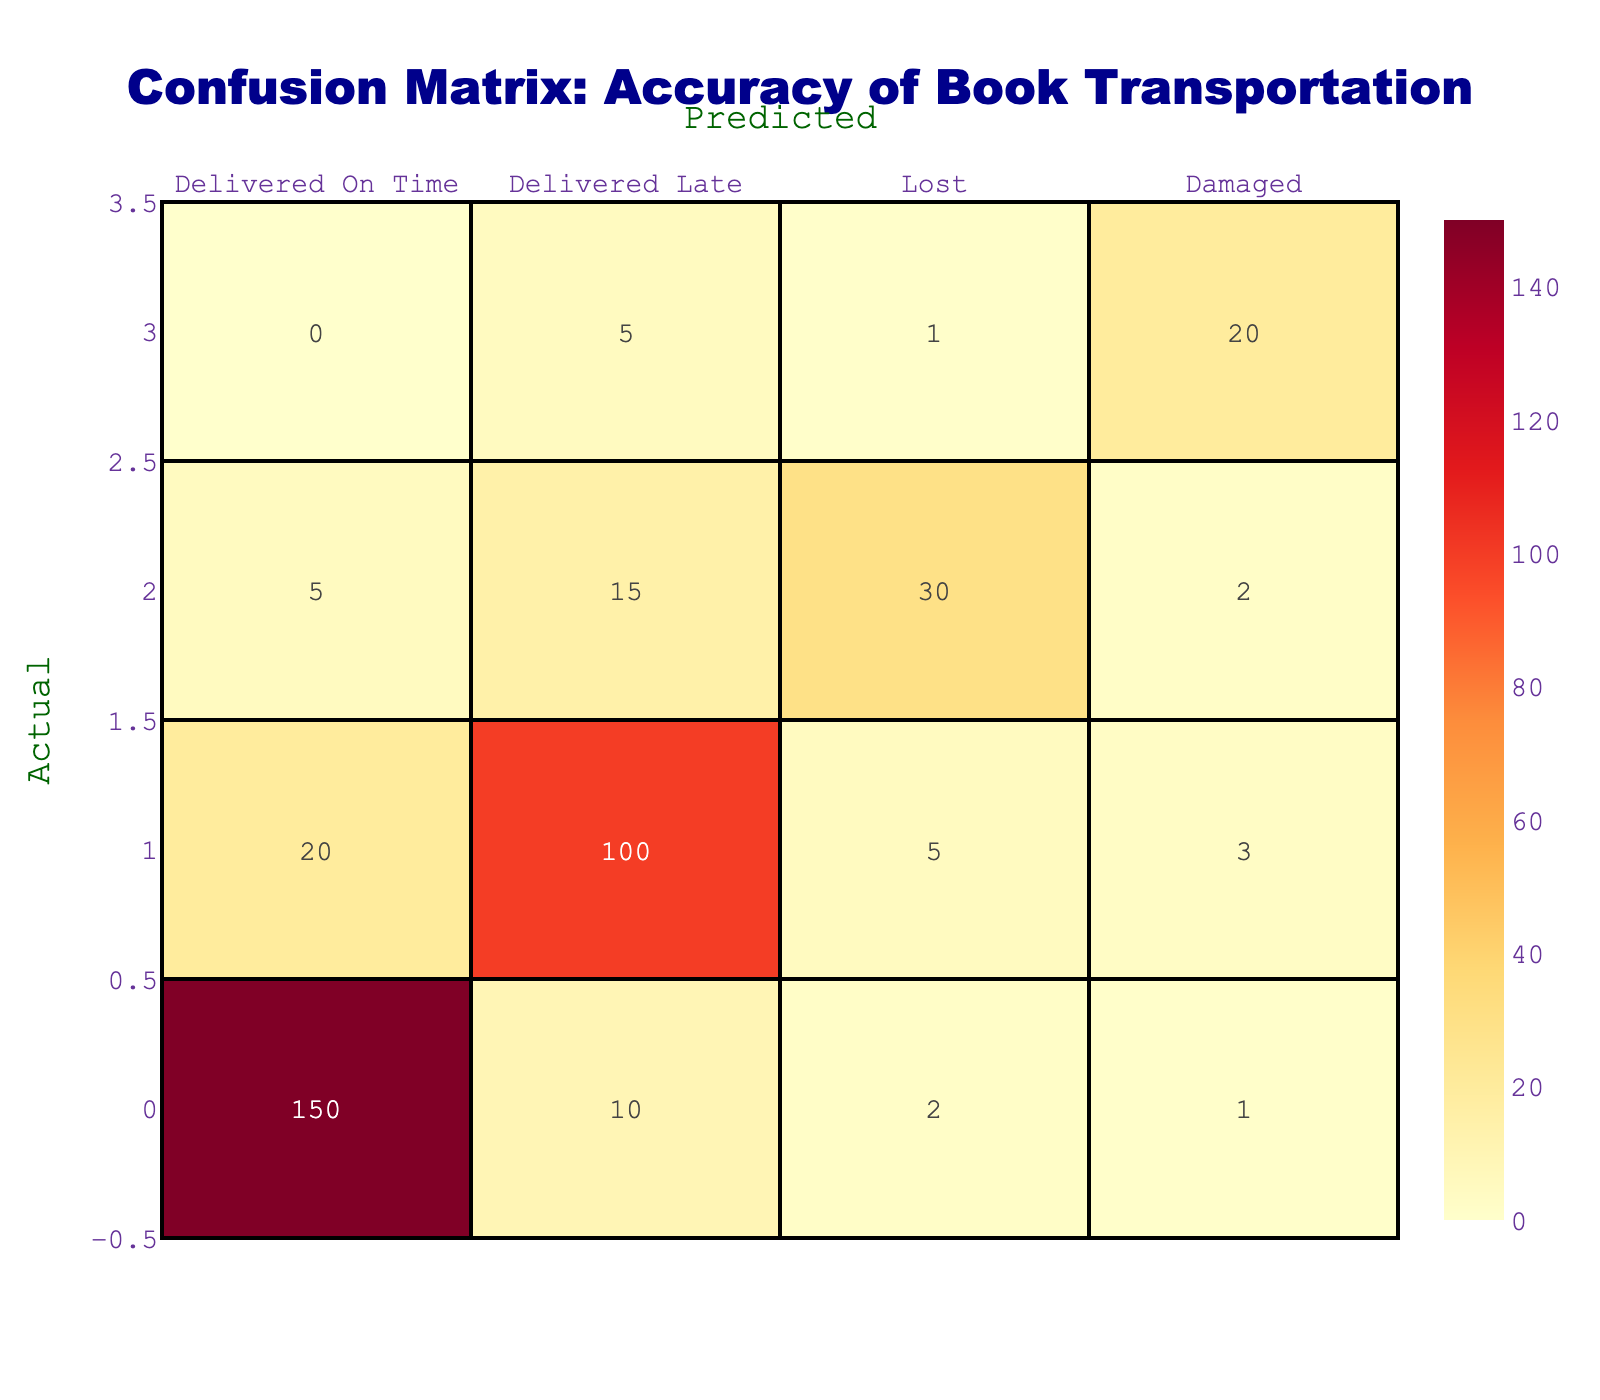What is the number of books that were delivered on time? Referring to the confusion matrix, I can see that the number of books delivered on time is listed in the first row under "Delivered On Time," which shows a value of 150.
Answer: 150 What is the total number of books that were damaged during transportation? The total number of books that were damaged is found in the fourth row under the column "Damaged." I sum up the values in that row: 0 (delivered on time) + 5 (delivered late) + 1 (lost) + 20 (damaged) = 26.
Answer: 26 Is it true that the number of books lost during transportation is higher than the number damaged? The number of books lost is 30, and the number damaged is 20. Since 30 is greater than 20, the statement is true.
Answer: Yes What was the total number of books delivered late? To find the total number of books delivered late, I look at the second row. I sum the values: 20 (delivered on time) + 100 (delivered late) + 5 (lost) + 3 (damaged) = 128.
Answer: 128 What percentage of the total predictions were correct (delivered on time)? To find the percentage of correct predictions (delivered on time), I need to take the value for "Delivered On Time" (150) from the confusion matrix and divide it by the total number of predictions made. The total is the sum of all values in the matrix: 150 + 10 + 2 + 1 + 20 + 100 + 5 + 3 + 5 + 15 + 30 + 2 + 0 + 5 + 1 + 20 = 400. The correct predictions are thus (150 / 400) * 100 = 37.5%.
Answer: 37.5% What is the difference between the number of books delivered late and the number of books delivered on time? Referring to the second row, the number of books delivered late is 100 and the number of books delivered on time is 150. To find the difference, I subtract: 150 - 100 = 50.
Answer: 50 What is the total sum of all predictions that ended up being lost? The third row lists the number of lost books in terms of predictions made. I add the numbers across that row: 5 (delivered on time) + 15 (delivered late) + 30 (lost) + 2 (damaged) = 52.
Answer: 52 Were more books delivered on time compared to those that were lost? The number of books delivered on time is 150, and the number lost is 30. Since 150 is greater than 30, the statement is true.
Answer: Yes How many books were delivered either on time or damaged? To find this, I add the delivered on time (150) and the damaged (20) books: 150 + 20 = 170 books fall into either category.
Answer: 170 